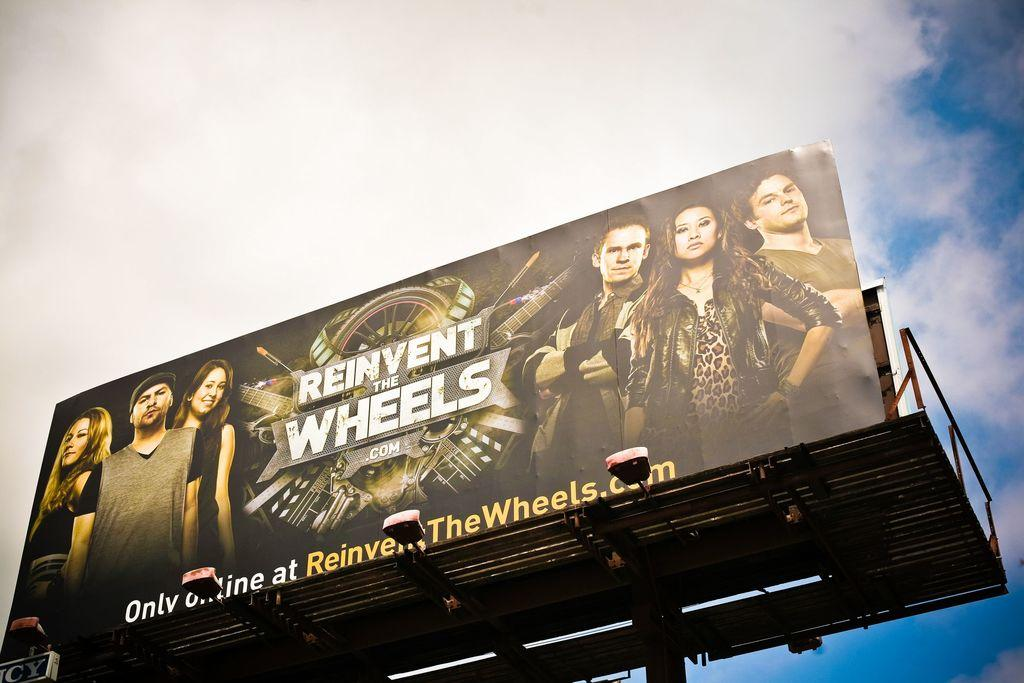<image>
Summarize the visual content of the image. An billboard advertisement for a show called, "reinvent the wheels". 